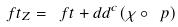Convert formula to latex. <formula><loc_0><loc_0><loc_500><loc_500>\ f t _ { Z } = \ f t + d d ^ { c } ( \chi \circ \ p )</formula> 